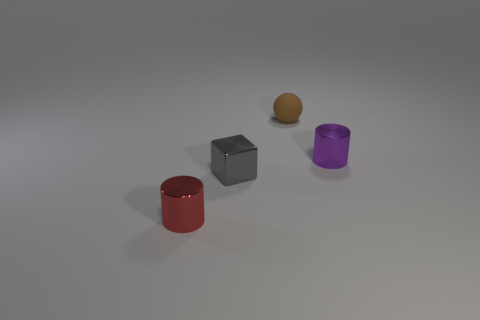Can you tell me the positioning of the objects with respect to each other? In relation to each other, from left to right, we have the red cylinder, the matte metal cube, the golden sphere, with the purple cylinder at the far right. The sphere is slightly behind the line formed by the other three objects. 